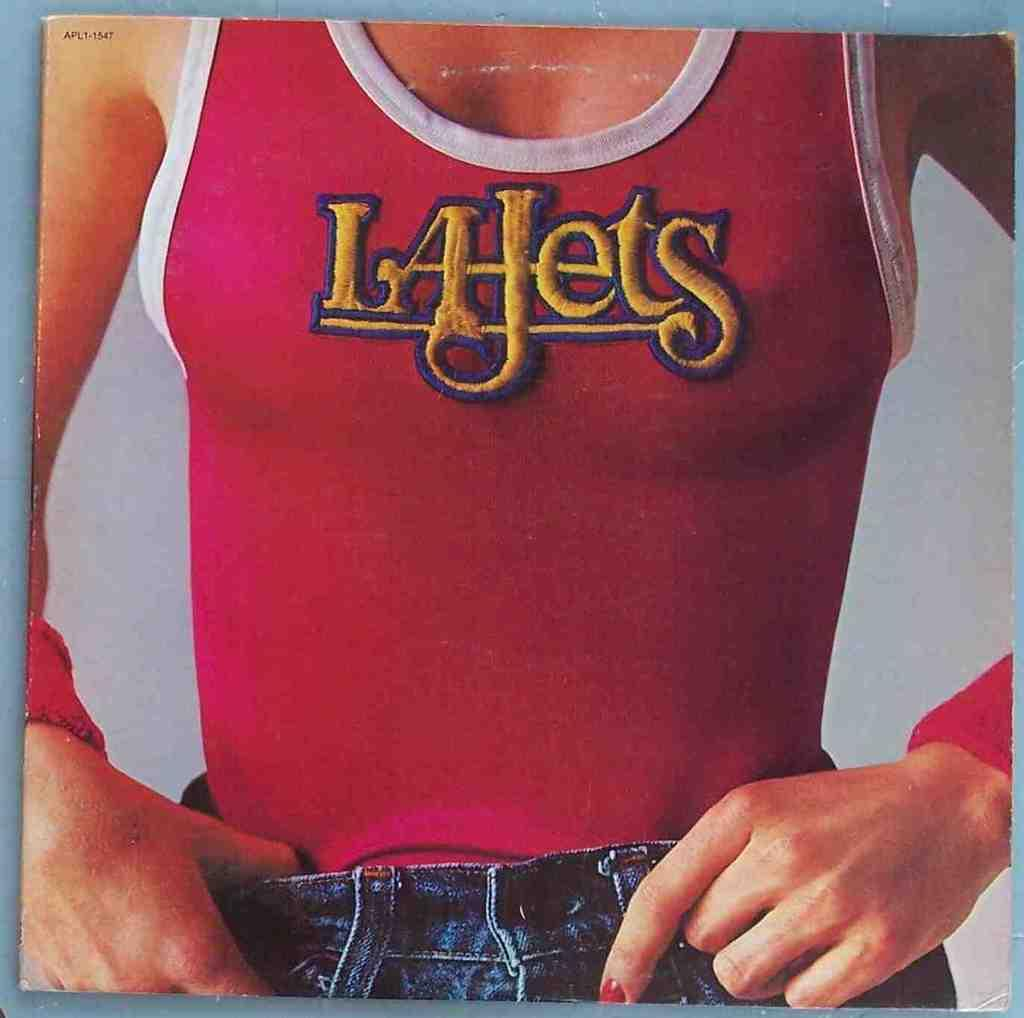<image>
Describe the image concisely. Advertisement for a shirt with the company name on it named Lajets. 